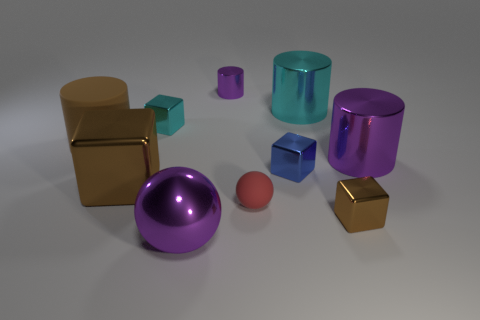Subtract all large brown cubes. How many cubes are left? 3 Subtract all brown cylinders. How many cylinders are left? 3 Subtract 3 cubes. How many cubes are left? 1 Subtract all yellow spheres. How many purple cylinders are left? 2 Subtract all spheres. How many objects are left? 8 Subtract all purple cylinders. Subtract all cyan cubes. How many cylinders are left? 2 Subtract all brown cylinders. Subtract all large brown cubes. How many objects are left? 8 Add 7 matte objects. How many matte objects are left? 9 Add 3 purple spheres. How many purple spheres exist? 4 Subtract 0 gray cylinders. How many objects are left? 10 